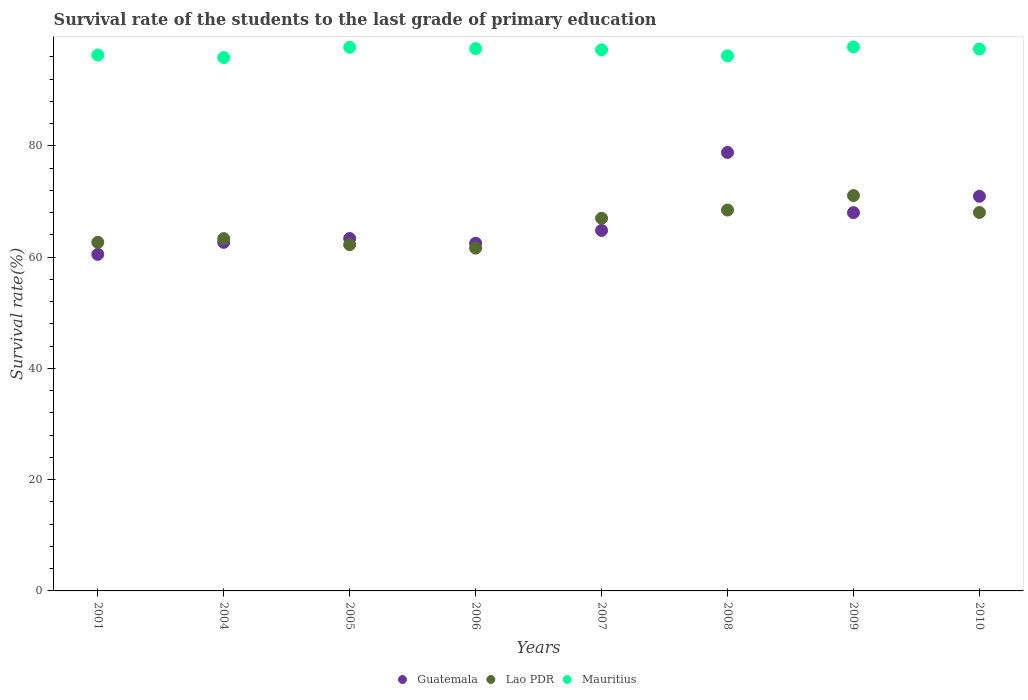How many different coloured dotlines are there?
Keep it short and to the point. 3. What is the survival rate of the students in Mauritius in 2009?
Offer a very short reply. 97.77. Across all years, what is the maximum survival rate of the students in Lao PDR?
Provide a short and direct response. 71.05. Across all years, what is the minimum survival rate of the students in Lao PDR?
Your response must be concise. 61.61. In which year was the survival rate of the students in Mauritius maximum?
Give a very brief answer. 2009. What is the total survival rate of the students in Guatemala in the graph?
Provide a short and direct response. 531.49. What is the difference between the survival rate of the students in Mauritius in 2004 and that in 2006?
Your answer should be very brief. -1.6. What is the difference between the survival rate of the students in Guatemala in 2004 and the survival rate of the students in Lao PDR in 2005?
Give a very brief answer. 0.41. What is the average survival rate of the students in Guatemala per year?
Provide a succinct answer. 66.44. In the year 2009, what is the difference between the survival rate of the students in Guatemala and survival rate of the students in Lao PDR?
Provide a succinct answer. -3.07. What is the ratio of the survival rate of the students in Lao PDR in 2001 to that in 2004?
Keep it short and to the point. 0.99. Is the survival rate of the students in Guatemala in 2001 less than that in 2008?
Keep it short and to the point. Yes. Is the difference between the survival rate of the students in Guatemala in 2001 and 2008 greater than the difference between the survival rate of the students in Lao PDR in 2001 and 2008?
Keep it short and to the point. No. What is the difference between the highest and the second highest survival rate of the students in Mauritius?
Your response must be concise. 0.06. What is the difference between the highest and the lowest survival rate of the students in Lao PDR?
Provide a short and direct response. 9.44. Is the sum of the survival rate of the students in Guatemala in 2006 and 2010 greater than the maximum survival rate of the students in Mauritius across all years?
Your answer should be very brief. Yes. Does the survival rate of the students in Mauritius monotonically increase over the years?
Offer a terse response. No. Is the survival rate of the students in Lao PDR strictly greater than the survival rate of the students in Mauritius over the years?
Your answer should be compact. No. Is the survival rate of the students in Guatemala strictly less than the survival rate of the students in Mauritius over the years?
Provide a short and direct response. Yes. How many dotlines are there?
Your answer should be very brief. 3. What is the difference between two consecutive major ticks on the Y-axis?
Give a very brief answer. 20. Are the values on the major ticks of Y-axis written in scientific E-notation?
Give a very brief answer. No. Does the graph contain any zero values?
Keep it short and to the point. No. How are the legend labels stacked?
Keep it short and to the point. Horizontal. What is the title of the graph?
Offer a terse response. Survival rate of the students to the last grade of primary education. What is the label or title of the X-axis?
Your response must be concise. Years. What is the label or title of the Y-axis?
Your response must be concise. Survival rate(%). What is the Survival rate(%) of Guatemala in 2001?
Provide a succinct answer. 60.49. What is the Survival rate(%) in Lao PDR in 2001?
Your answer should be compact. 62.66. What is the Survival rate(%) of Mauritius in 2001?
Keep it short and to the point. 96.32. What is the Survival rate(%) of Guatemala in 2004?
Provide a succinct answer. 62.65. What is the Survival rate(%) of Lao PDR in 2004?
Your response must be concise. 63.33. What is the Survival rate(%) of Mauritius in 2004?
Offer a very short reply. 95.87. What is the Survival rate(%) in Guatemala in 2005?
Give a very brief answer. 63.34. What is the Survival rate(%) in Lao PDR in 2005?
Offer a terse response. 62.23. What is the Survival rate(%) of Mauritius in 2005?
Ensure brevity in your answer.  97.71. What is the Survival rate(%) of Guatemala in 2006?
Provide a short and direct response. 62.49. What is the Survival rate(%) in Lao PDR in 2006?
Offer a very short reply. 61.61. What is the Survival rate(%) of Mauritius in 2006?
Keep it short and to the point. 97.47. What is the Survival rate(%) of Guatemala in 2007?
Provide a short and direct response. 64.79. What is the Survival rate(%) of Lao PDR in 2007?
Provide a short and direct response. 66.98. What is the Survival rate(%) of Mauritius in 2007?
Keep it short and to the point. 97.25. What is the Survival rate(%) of Guatemala in 2008?
Provide a short and direct response. 78.81. What is the Survival rate(%) of Lao PDR in 2008?
Provide a succinct answer. 68.45. What is the Survival rate(%) in Mauritius in 2008?
Provide a succinct answer. 96.17. What is the Survival rate(%) of Guatemala in 2009?
Give a very brief answer. 67.98. What is the Survival rate(%) of Lao PDR in 2009?
Your answer should be compact. 71.05. What is the Survival rate(%) in Mauritius in 2009?
Your response must be concise. 97.77. What is the Survival rate(%) of Guatemala in 2010?
Make the answer very short. 70.93. What is the Survival rate(%) of Lao PDR in 2010?
Give a very brief answer. 68.02. What is the Survival rate(%) in Mauritius in 2010?
Provide a succinct answer. 97.4. Across all years, what is the maximum Survival rate(%) of Guatemala?
Provide a succinct answer. 78.81. Across all years, what is the maximum Survival rate(%) in Lao PDR?
Offer a terse response. 71.05. Across all years, what is the maximum Survival rate(%) in Mauritius?
Ensure brevity in your answer.  97.77. Across all years, what is the minimum Survival rate(%) in Guatemala?
Your answer should be very brief. 60.49. Across all years, what is the minimum Survival rate(%) in Lao PDR?
Offer a terse response. 61.61. Across all years, what is the minimum Survival rate(%) of Mauritius?
Your answer should be very brief. 95.87. What is the total Survival rate(%) of Guatemala in the graph?
Offer a terse response. 531.49. What is the total Survival rate(%) of Lao PDR in the graph?
Give a very brief answer. 524.33. What is the total Survival rate(%) of Mauritius in the graph?
Offer a terse response. 775.96. What is the difference between the Survival rate(%) in Guatemala in 2001 and that in 2004?
Offer a terse response. -2.16. What is the difference between the Survival rate(%) of Lao PDR in 2001 and that in 2004?
Your answer should be compact. -0.67. What is the difference between the Survival rate(%) of Mauritius in 2001 and that in 2004?
Your answer should be compact. 0.45. What is the difference between the Survival rate(%) of Guatemala in 2001 and that in 2005?
Provide a short and direct response. -2.85. What is the difference between the Survival rate(%) of Lao PDR in 2001 and that in 2005?
Your answer should be compact. 0.42. What is the difference between the Survival rate(%) in Mauritius in 2001 and that in 2005?
Offer a terse response. -1.39. What is the difference between the Survival rate(%) of Guatemala in 2001 and that in 2006?
Your response must be concise. -2. What is the difference between the Survival rate(%) of Lao PDR in 2001 and that in 2006?
Your answer should be very brief. 1.04. What is the difference between the Survival rate(%) of Mauritius in 2001 and that in 2006?
Your answer should be very brief. -1.15. What is the difference between the Survival rate(%) of Guatemala in 2001 and that in 2007?
Make the answer very short. -4.3. What is the difference between the Survival rate(%) of Lao PDR in 2001 and that in 2007?
Your answer should be very brief. -4.32. What is the difference between the Survival rate(%) of Mauritius in 2001 and that in 2007?
Your answer should be compact. -0.93. What is the difference between the Survival rate(%) in Guatemala in 2001 and that in 2008?
Your answer should be very brief. -18.32. What is the difference between the Survival rate(%) in Lao PDR in 2001 and that in 2008?
Ensure brevity in your answer.  -5.8. What is the difference between the Survival rate(%) in Mauritius in 2001 and that in 2008?
Keep it short and to the point. 0.15. What is the difference between the Survival rate(%) in Guatemala in 2001 and that in 2009?
Your response must be concise. -7.49. What is the difference between the Survival rate(%) of Lao PDR in 2001 and that in 2009?
Ensure brevity in your answer.  -8.4. What is the difference between the Survival rate(%) of Mauritius in 2001 and that in 2009?
Ensure brevity in your answer.  -1.45. What is the difference between the Survival rate(%) in Guatemala in 2001 and that in 2010?
Ensure brevity in your answer.  -10.44. What is the difference between the Survival rate(%) of Lao PDR in 2001 and that in 2010?
Your answer should be very brief. -5.36. What is the difference between the Survival rate(%) in Mauritius in 2001 and that in 2010?
Offer a terse response. -1.08. What is the difference between the Survival rate(%) in Guatemala in 2004 and that in 2005?
Keep it short and to the point. -0.69. What is the difference between the Survival rate(%) in Lao PDR in 2004 and that in 2005?
Ensure brevity in your answer.  1.09. What is the difference between the Survival rate(%) of Mauritius in 2004 and that in 2005?
Your response must be concise. -1.84. What is the difference between the Survival rate(%) of Guatemala in 2004 and that in 2006?
Provide a short and direct response. 0.15. What is the difference between the Survival rate(%) of Lao PDR in 2004 and that in 2006?
Your answer should be compact. 1.71. What is the difference between the Survival rate(%) of Mauritius in 2004 and that in 2006?
Offer a terse response. -1.6. What is the difference between the Survival rate(%) in Guatemala in 2004 and that in 2007?
Your response must be concise. -2.14. What is the difference between the Survival rate(%) in Lao PDR in 2004 and that in 2007?
Your answer should be compact. -3.65. What is the difference between the Survival rate(%) in Mauritius in 2004 and that in 2007?
Offer a very short reply. -1.38. What is the difference between the Survival rate(%) in Guatemala in 2004 and that in 2008?
Your answer should be compact. -16.16. What is the difference between the Survival rate(%) of Lao PDR in 2004 and that in 2008?
Your answer should be very brief. -5.13. What is the difference between the Survival rate(%) of Mauritius in 2004 and that in 2008?
Your response must be concise. -0.3. What is the difference between the Survival rate(%) of Guatemala in 2004 and that in 2009?
Ensure brevity in your answer.  -5.34. What is the difference between the Survival rate(%) in Lao PDR in 2004 and that in 2009?
Provide a short and direct response. -7.73. What is the difference between the Survival rate(%) of Mauritius in 2004 and that in 2009?
Ensure brevity in your answer.  -1.9. What is the difference between the Survival rate(%) of Guatemala in 2004 and that in 2010?
Your answer should be very brief. -8.28. What is the difference between the Survival rate(%) in Lao PDR in 2004 and that in 2010?
Your answer should be very brief. -4.69. What is the difference between the Survival rate(%) of Mauritius in 2004 and that in 2010?
Keep it short and to the point. -1.53. What is the difference between the Survival rate(%) of Guatemala in 2005 and that in 2006?
Give a very brief answer. 0.85. What is the difference between the Survival rate(%) of Lao PDR in 2005 and that in 2006?
Your answer should be compact. 0.62. What is the difference between the Survival rate(%) of Mauritius in 2005 and that in 2006?
Provide a succinct answer. 0.24. What is the difference between the Survival rate(%) in Guatemala in 2005 and that in 2007?
Your answer should be compact. -1.45. What is the difference between the Survival rate(%) of Lao PDR in 2005 and that in 2007?
Your answer should be very brief. -4.74. What is the difference between the Survival rate(%) in Mauritius in 2005 and that in 2007?
Provide a succinct answer. 0.45. What is the difference between the Survival rate(%) in Guatemala in 2005 and that in 2008?
Provide a short and direct response. -15.47. What is the difference between the Survival rate(%) of Lao PDR in 2005 and that in 2008?
Make the answer very short. -6.22. What is the difference between the Survival rate(%) in Mauritius in 2005 and that in 2008?
Ensure brevity in your answer.  1.54. What is the difference between the Survival rate(%) of Guatemala in 2005 and that in 2009?
Make the answer very short. -4.64. What is the difference between the Survival rate(%) of Lao PDR in 2005 and that in 2009?
Your answer should be very brief. -8.82. What is the difference between the Survival rate(%) in Mauritius in 2005 and that in 2009?
Your answer should be very brief. -0.06. What is the difference between the Survival rate(%) of Guatemala in 2005 and that in 2010?
Your response must be concise. -7.58. What is the difference between the Survival rate(%) in Lao PDR in 2005 and that in 2010?
Give a very brief answer. -5.78. What is the difference between the Survival rate(%) of Mauritius in 2005 and that in 2010?
Ensure brevity in your answer.  0.31. What is the difference between the Survival rate(%) of Guatemala in 2006 and that in 2007?
Ensure brevity in your answer.  -2.3. What is the difference between the Survival rate(%) in Lao PDR in 2006 and that in 2007?
Provide a succinct answer. -5.36. What is the difference between the Survival rate(%) in Mauritius in 2006 and that in 2007?
Your response must be concise. 0.22. What is the difference between the Survival rate(%) in Guatemala in 2006 and that in 2008?
Provide a succinct answer. -16.32. What is the difference between the Survival rate(%) of Lao PDR in 2006 and that in 2008?
Your response must be concise. -6.84. What is the difference between the Survival rate(%) of Mauritius in 2006 and that in 2008?
Give a very brief answer. 1.3. What is the difference between the Survival rate(%) in Guatemala in 2006 and that in 2009?
Your answer should be very brief. -5.49. What is the difference between the Survival rate(%) in Lao PDR in 2006 and that in 2009?
Offer a terse response. -9.44. What is the difference between the Survival rate(%) of Mauritius in 2006 and that in 2009?
Offer a very short reply. -0.3. What is the difference between the Survival rate(%) of Guatemala in 2006 and that in 2010?
Provide a short and direct response. -8.43. What is the difference between the Survival rate(%) in Lao PDR in 2006 and that in 2010?
Keep it short and to the point. -6.4. What is the difference between the Survival rate(%) in Mauritius in 2006 and that in 2010?
Offer a terse response. 0.08. What is the difference between the Survival rate(%) of Guatemala in 2007 and that in 2008?
Keep it short and to the point. -14.02. What is the difference between the Survival rate(%) of Lao PDR in 2007 and that in 2008?
Offer a terse response. -1.48. What is the difference between the Survival rate(%) in Mauritius in 2007 and that in 2008?
Keep it short and to the point. 1.09. What is the difference between the Survival rate(%) in Guatemala in 2007 and that in 2009?
Make the answer very short. -3.19. What is the difference between the Survival rate(%) in Lao PDR in 2007 and that in 2009?
Your response must be concise. -4.08. What is the difference between the Survival rate(%) of Mauritius in 2007 and that in 2009?
Your response must be concise. -0.51. What is the difference between the Survival rate(%) of Guatemala in 2007 and that in 2010?
Ensure brevity in your answer.  -6.14. What is the difference between the Survival rate(%) of Lao PDR in 2007 and that in 2010?
Offer a very short reply. -1.04. What is the difference between the Survival rate(%) in Mauritius in 2007 and that in 2010?
Ensure brevity in your answer.  -0.14. What is the difference between the Survival rate(%) of Guatemala in 2008 and that in 2009?
Offer a terse response. 10.83. What is the difference between the Survival rate(%) in Lao PDR in 2008 and that in 2009?
Ensure brevity in your answer.  -2.6. What is the difference between the Survival rate(%) in Mauritius in 2008 and that in 2009?
Ensure brevity in your answer.  -1.6. What is the difference between the Survival rate(%) of Guatemala in 2008 and that in 2010?
Provide a succinct answer. 7.89. What is the difference between the Survival rate(%) of Lao PDR in 2008 and that in 2010?
Keep it short and to the point. 0.44. What is the difference between the Survival rate(%) in Mauritius in 2008 and that in 2010?
Offer a very short reply. -1.23. What is the difference between the Survival rate(%) of Guatemala in 2009 and that in 2010?
Your response must be concise. -2.94. What is the difference between the Survival rate(%) in Lao PDR in 2009 and that in 2010?
Give a very brief answer. 3.04. What is the difference between the Survival rate(%) in Mauritius in 2009 and that in 2010?
Your response must be concise. 0.37. What is the difference between the Survival rate(%) in Guatemala in 2001 and the Survival rate(%) in Lao PDR in 2004?
Your answer should be very brief. -2.84. What is the difference between the Survival rate(%) in Guatemala in 2001 and the Survival rate(%) in Mauritius in 2004?
Offer a terse response. -35.38. What is the difference between the Survival rate(%) in Lao PDR in 2001 and the Survival rate(%) in Mauritius in 2004?
Give a very brief answer. -33.21. What is the difference between the Survival rate(%) in Guatemala in 2001 and the Survival rate(%) in Lao PDR in 2005?
Offer a very short reply. -1.74. What is the difference between the Survival rate(%) of Guatemala in 2001 and the Survival rate(%) of Mauritius in 2005?
Provide a succinct answer. -37.22. What is the difference between the Survival rate(%) in Lao PDR in 2001 and the Survival rate(%) in Mauritius in 2005?
Ensure brevity in your answer.  -35.05. What is the difference between the Survival rate(%) in Guatemala in 2001 and the Survival rate(%) in Lao PDR in 2006?
Provide a short and direct response. -1.12. What is the difference between the Survival rate(%) in Guatemala in 2001 and the Survival rate(%) in Mauritius in 2006?
Give a very brief answer. -36.98. What is the difference between the Survival rate(%) in Lao PDR in 2001 and the Survival rate(%) in Mauritius in 2006?
Your answer should be compact. -34.82. What is the difference between the Survival rate(%) in Guatemala in 2001 and the Survival rate(%) in Lao PDR in 2007?
Ensure brevity in your answer.  -6.49. What is the difference between the Survival rate(%) in Guatemala in 2001 and the Survival rate(%) in Mauritius in 2007?
Offer a very short reply. -36.76. What is the difference between the Survival rate(%) of Lao PDR in 2001 and the Survival rate(%) of Mauritius in 2007?
Provide a short and direct response. -34.6. What is the difference between the Survival rate(%) in Guatemala in 2001 and the Survival rate(%) in Lao PDR in 2008?
Offer a very short reply. -7.96. What is the difference between the Survival rate(%) in Guatemala in 2001 and the Survival rate(%) in Mauritius in 2008?
Give a very brief answer. -35.68. What is the difference between the Survival rate(%) in Lao PDR in 2001 and the Survival rate(%) in Mauritius in 2008?
Your answer should be compact. -33.51. What is the difference between the Survival rate(%) in Guatemala in 2001 and the Survival rate(%) in Lao PDR in 2009?
Provide a succinct answer. -10.56. What is the difference between the Survival rate(%) in Guatemala in 2001 and the Survival rate(%) in Mauritius in 2009?
Your answer should be very brief. -37.28. What is the difference between the Survival rate(%) of Lao PDR in 2001 and the Survival rate(%) of Mauritius in 2009?
Ensure brevity in your answer.  -35.11. What is the difference between the Survival rate(%) of Guatemala in 2001 and the Survival rate(%) of Lao PDR in 2010?
Make the answer very short. -7.53. What is the difference between the Survival rate(%) of Guatemala in 2001 and the Survival rate(%) of Mauritius in 2010?
Provide a short and direct response. -36.91. What is the difference between the Survival rate(%) of Lao PDR in 2001 and the Survival rate(%) of Mauritius in 2010?
Your answer should be very brief. -34.74. What is the difference between the Survival rate(%) in Guatemala in 2004 and the Survival rate(%) in Lao PDR in 2005?
Ensure brevity in your answer.  0.41. What is the difference between the Survival rate(%) in Guatemala in 2004 and the Survival rate(%) in Mauritius in 2005?
Provide a short and direct response. -35.06. What is the difference between the Survival rate(%) in Lao PDR in 2004 and the Survival rate(%) in Mauritius in 2005?
Offer a very short reply. -34.38. What is the difference between the Survival rate(%) in Guatemala in 2004 and the Survival rate(%) in Lao PDR in 2006?
Provide a short and direct response. 1.04. What is the difference between the Survival rate(%) of Guatemala in 2004 and the Survival rate(%) of Mauritius in 2006?
Make the answer very short. -34.82. What is the difference between the Survival rate(%) of Lao PDR in 2004 and the Survival rate(%) of Mauritius in 2006?
Offer a very short reply. -34.15. What is the difference between the Survival rate(%) of Guatemala in 2004 and the Survival rate(%) of Lao PDR in 2007?
Provide a succinct answer. -4.33. What is the difference between the Survival rate(%) of Guatemala in 2004 and the Survival rate(%) of Mauritius in 2007?
Provide a succinct answer. -34.61. What is the difference between the Survival rate(%) in Lao PDR in 2004 and the Survival rate(%) in Mauritius in 2007?
Your response must be concise. -33.93. What is the difference between the Survival rate(%) of Guatemala in 2004 and the Survival rate(%) of Lao PDR in 2008?
Ensure brevity in your answer.  -5.8. What is the difference between the Survival rate(%) in Guatemala in 2004 and the Survival rate(%) in Mauritius in 2008?
Provide a short and direct response. -33.52. What is the difference between the Survival rate(%) in Lao PDR in 2004 and the Survival rate(%) in Mauritius in 2008?
Ensure brevity in your answer.  -32.84. What is the difference between the Survival rate(%) in Guatemala in 2004 and the Survival rate(%) in Lao PDR in 2009?
Your answer should be very brief. -8.41. What is the difference between the Survival rate(%) of Guatemala in 2004 and the Survival rate(%) of Mauritius in 2009?
Offer a terse response. -35.12. What is the difference between the Survival rate(%) in Lao PDR in 2004 and the Survival rate(%) in Mauritius in 2009?
Your response must be concise. -34.44. What is the difference between the Survival rate(%) of Guatemala in 2004 and the Survival rate(%) of Lao PDR in 2010?
Provide a short and direct response. -5.37. What is the difference between the Survival rate(%) of Guatemala in 2004 and the Survival rate(%) of Mauritius in 2010?
Give a very brief answer. -34.75. What is the difference between the Survival rate(%) of Lao PDR in 2004 and the Survival rate(%) of Mauritius in 2010?
Your answer should be very brief. -34.07. What is the difference between the Survival rate(%) in Guatemala in 2005 and the Survival rate(%) in Lao PDR in 2006?
Your answer should be compact. 1.73. What is the difference between the Survival rate(%) in Guatemala in 2005 and the Survival rate(%) in Mauritius in 2006?
Make the answer very short. -34.13. What is the difference between the Survival rate(%) in Lao PDR in 2005 and the Survival rate(%) in Mauritius in 2006?
Keep it short and to the point. -35.24. What is the difference between the Survival rate(%) in Guatemala in 2005 and the Survival rate(%) in Lao PDR in 2007?
Make the answer very short. -3.63. What is the difference between the Survival rate(%) of Guatemala in 2005 and the Survival rate(%) of Mauritius in 2007?
Make the answer very short. -33.91. What is the difference between the Survival rate(%) in Lao PDR in 2005 and the Survival rate(%) in Mauritius in 2007?
Your answer should be very brief. -35.02. What is the difference between the Survival rate(%) in Guatemala in 2005 and the Survival rate(%) in Lao PDR in 2008?
Ensure brevity in your answer.  -5.11. What is the difference between the Survival rate(%) in Guatemala in 2005 and the Survival rate(%) in Mauritius in 2008?
Give a very brief answer. -32.83. What is the difference between the Survival rate(%) in Lao PDR in 2005 and the Survival rate(%) in Mauritius in 2008?
Provide a succinct answer. -33.93. What is the difference between the Survival rate(%) of Guatemala in 2005 and the Survival rate(%) of Lao PDR in 2009?
Offer a terse response. -7.71. What is the difference between the Survival rate(%) of Guatemala in 2005 and the Survival rate(%) of Mauritius in 2009?
Your answer should be very brief. -34.43. What is the difference between the Survival rate(%) in Lao PDR in 2005 and the Survival rate(%) in Mauritius in 2009?
Your answer should be very brief. -35.53. What is the difference between the Survival rate(%) of Guatemala in 2005 and the Survival rate(%) of Lao PDR in 2010?
Provide a short and direct response. -4.67. What is the difference between the Survival rate(%) of Guatemala in 2005 and the Survival rate(%) of Mauritius in 2010?
Ensure brevity in your answer.  -34.05. What is the difference between the Survival rate(%) in Lao PDR in 2005 and the Survival rate(%) in Mauritius in 2010?
Offer a terse response. -35.16. What is the difference between the Survival rate(%) of Guatemala in 2006 and the Survival rate(%) of Lao PDR in 2007?
Provide a succinct answer. -4.48. What is the difference between the Survival rate(%) in Guatemala in 2006 and the Survival rate(%) in Mauritius in 2007?
Your answer should be compact. -34.76. What is the difference between the Survival rate(%) in Lao PDR in 2006 and the Survival rate(%) in Mauritius in 2007?
Make the answer very short. -35.64. What is the difference between the Survival rate(%) of Guatemala in 2006 and the Survival rate(%) of Lao PDR in 2008?
Provide a succinct answer. -5.96. What is the difference between the Survival rate(%) of Guatemala in 2006 and the Survival rate(%) of Mauritius in 2008?
Ensure brevity in your answer.  -33.67. What is the difference between the Survival rate(%) in Lao PDR in 2006 and the Survival rate(%) in Mauritius in 2008?
Make the answer very short. -34.56. What is the difference between the Survival rate(%) of Guatemala in 2006 and the Survival rate(%) of Lao PDR in 2009?
Your answer should be very brief. -8.56. What is the difference between the Survival rate(%) of Guatemala in 2006 and the Survival rate(%) of Mauritius in 2009?
Offer a terse response. -35.27. What is the difference between the Survival rate(%) in Lao PDR in 2006 and the Survival rate(%) in Mauritius in 2009?
Make the answer very short. -36.15. What is the difference between the Survival rate(%) of Guatemala in 2006 and the Survival rate(%) of Lao PDR in 2010?
Keep it short and to the point. -5.52. What is the difference between the Survival rate(%) of Guatemala in 2006 and the Survival rate(%) of Mauritius in 2010?
Provide a short and direct response. -34.9. What is the difference between the Survival rate(%) in Lao PDR in 2006 and the Survival rate(%) in Mauritius in 2010?
Offer a terse response. -35.78. What is the difference between the Survival rate(%) in Guatemala in 2007 and the Survival rate(%) in Lao PDR in 2008?
Offer a very short reply. -3.66. What is the difference between the Survival rate(%) of Guatemala in 2007 and the Survival rate(%) of Mauritius in 2008?
Offer a terse response. -31.38. What is the difference between the Survival rate(%) in Lao PDR in 2007 and the Survival rate(%) in Mauritius in 2008?
Offer a terse response. -29.19. What is the difference between the Survival rate(%) of Guatemala in 2007 and the Survival rate(%) of Lao PDR in 2009?
Keep it short and to the point. -6.26. What is the difference between the Survival rate(%) of Guatemala in 2007 and the Survival rate(%) of Mauritius in 2009?
Provide a short and direct response. -32.98. What is the difference between the Survival rate(%) of Lao PDR in 2007 and the Survival rate(%) of Mauritius in 2009?
Provide a succinct answer. -30.79. What is the difference between the Survival rate(%) of Guatemala in 2007 and the Survival rate(%) of Lao PDR in 2010?
Make the answer very short. -3.23. What is the difference between the Survival rate(%) of Guatemala in 2007 and the Survival rate(%) of Mauritius in 2010?
Your answer should be compact. -32.61. What is the difference between the Survival rate(%) of Lao PDR in 2007 and the Survival rate(%) of Mauritius in 2010?
Ensure brevity in your answer.  -30.42. What is the difference between the Survival rate(%) of Guatemala in 2008 and the Survival rate(%) of Lao PDR in 2009?
Make the answer very short. 7.76. What is the difference between the Survival rate(%) of Guatemala in 2008 and the Survival rate(%) of Mauritius in 2009?
Your answer should be compact. -18.95. What is the difference between the Survival rate(%) of Lao PDR in 2008 and the Survival rate(%) of Mauritius in 2009?
Ensure brevity in your answer.  -29.32. What is the difference between the Survival rate(%) in Guatemala in 2008 and the Survival rate(%) in Lao PDR in 2010?
Ensure brevity in your answer.  10.8. What is the difference between the Survival rate(%) in Guatemala in 2008 and the Survival rate(%) in Mauritius in 2010?
Ensure brevity in your answer.  -18.58. What is the difference between the Survival rate(%) of Lao PDR in 2008 and the Survival rate(%) of Mauritius in 2010?
Your answer should be compact. -28.94. What is the difference between the Survival rate(%) in Guatemala in 2009 and the Survival rate(%) in Lao PDR in 2010?
Provide a succinct answer. -0.03. What is the difference between the Survival rate(%) in Guatemala in 2009 and the Survival rate(%) in Mauritius in 2010?
Give a very brief answer. -29.41. What is the difference between the Survival rate(%) of Lao PDR in 2009 and the Survival rate(%) of Mauritius in 2010?
Ensure brevity in your answer.  -26.34. What is the average Survival rate(%) in Guatemala per year?
Your response must be concise. 66.44. What is the average Survival rate(%) of Lao PDR per year?
Give a very brief answer. 65.54. What is the average Survival rate(%) of Mauritius per year?
Keep it short and to the point. 96.99. In the year 2001, what is the difference between the Survival rate(%) of Guatemala and Survival rate(%) of Lao PDR?
Give a very brief answer. -2.17. In the year 2001, what is the difference between the Survival rate(%) in Guatemala and Survival rate(%) in Mauritius?
Give a very brief answer. -35.83. In the year 2001, what is the difference between the Survival rate(%) of Lao PDR and Survival rate(%) of Mauritius?
Make the answer very short. -33.66. In the year 2004, what is the difference between the Survival rate(%) of Guatemala and Survival rate(%) of Lao PDR?
Make the answer very short. -0.68. In the year 2004, what is the difference between the Survival rate(%) of Guatemala and Survival rate(%) of Mauritius?
Keep it short and to the point. -33.22. In the year 2004, what is the difference between the Survival rate(%) of Lao PDR and Survival rate(%) of Mauritius?
Provide a succinct answer. -32.54. In the year 2005, what is the difference between the Survival rate(%) of Guatemala and Survival rate(%) of Lao PDR?
Offer a very short reply. 1.11. In the year 2005, what is the difference between the Survival rate(%) of Guatemala and Survival rate(%) of Mauritius?
Ensure brevity in your answer.  -34.37. In the year 2005, what is the difference between the Survival rate(%) in Lao PDR and Survival rate(%) in Mauritius?
Your answer should be compact. -35.48. In the year 2006, what is the difference between the Survival rate(%) in Guatemala and Survival rate(%) in Lao PDR?
Your answer should be compact. 0.88. In the year 2006, what is the difference between the Survival rate(%) of Guatemala and Survival rate(%) of Mauritius?
Give a very brief answer. -34.98. In the year 2006, what is the difference between the Survival rate(%) of Lao PDR and Survival rate(%) of Mauritius?
Give a very brief answer. -35.86. In the year 2007, what is the difference between the Survival rate(%) in Guatemala and Survival rate(%) in Lao PDR?
Your response must be concise. -2.18. In the year 2007, what is the difference between the Survival rate(%) in Guatemala and Survival rate(%) in Mauritius?
Provide a short and direct response. -32.46. In the year 2007, what is the difference between the Survival rate(%) in Lao PDR and Survival rate(%) in Mauritius?
Offer a terse response. -30.28. In the year 2008, what is the difference between the Survival rate(%) of Guatemala and Survival rate(%) of Lao PDR?
Your answer should be compact. 10.36. In the year 2008, what is the difference between the Survival rate(%) of Guatemala and Survival rate(%) of Mauritius?
Give a very brief answer. -17.36. In the year 2008, what is the difference between the Survival rate(%) in Lao PDR and Survival rate(%) in Mauritius?
Provide a short and direct response. -27.72. In the year 2009, what is the difference between the Survival rate(%) of Guatemala and Survival rate(%) of Lao PDR?
Make the answer very short. -3.07. In the year 2009, what is the difference between the Survival rate(%) in Guatemala and Survival rate(%) in Mauritius?
Provide a short and direct response. -29.78. In the year 2009, what is the difference between the Survival rate(%) in Lao PDR and Survival rate(%) in Mauritius?
Offer a terse response. -26.71. In the year 2010, what is the difference between the Survival rate(%) in Guatemala and Survival rate(%) in Lao PDR?
Give a very brief answer. 2.91. In the year 2010, what is the difference between the Survival rate(%) of Guatemala and Survival rate(%) of Mauritius?
Make the answer very short. -26.47. In the year 2010, what is the difference between the Survival rate(%) in Lao PDR and Survival rate(%) in Mauritius?
Provide a succinct answer. -29.38. What is the ratio of the Survival rate(%) of Guatemala in 2001 to that in 2004?
Provide a succinct answer. 0.97. What is the ratio of the Survival rate(%) in Lao PDR in 2001 to that in 2004?
Give a very brief answer. 0.99. What is the ratio of the Survival rate(%) in Guatemala in 2001 to that in 2005?
Keep it short and to the point. 0.95. What is the ratio of the Survival rate(%) in Lao PDR in 2001 to that in 2005?
Your answer should be very brief. 1.01. What is the ratio of the Survival rate(%) of Mauritius in 2001 to that in 2005?
Give a very brief answer. 0.99. What is the ratio of the Survival rate(%) in Guatemala in 2001 to that in 2006?
Your response must be concise. 0.97. What is the ratio of the Survival rate(%) of Lao PDR in 2001 to that in 2006?
Give a very brief answer. 1.02. What is the ratio of the Survival rate(%) in Mauritius in 2001 to that in 2006?
Your answer should be compact. 0.99. What is the ratio of the Survival rate(%) in Guatemala in 2001 to that in 2007?
Provide a short and direct response. 0.93. What is the ratio of the Survival rate(%) in Lao PDR in 2001 to that in 2007?
Give a very brief answer. 0.94. What is the ratio of the Survival rate(%) of Guatemala in 2001 to that in 2008?
Ensure brevity in your answer.  0.77. What is the ratio of the Survival rate(%) in Lao PDR in 2001 to that in 2008?
Give a very brief answer. 0.92. What is the ratio of the Survival rate(%) of Mauritius in 2001 to that in 2008?
Provide a succinct answer. 1. What is the ratio of the Survival rate(%) of Guatemala in 2001 to that in 2009?
Offer a terse response. 0.89. What is the ratio of the Survival rate(%) in Lao PDR in 2001 to that in 2009?
Ensure brevity in your answer.  0.88. What is the ratio of the Survival rate(%) in Mauritius in 2001 to that in 2009?
Provide a short and direct response. 0.99. What is the ratio of the Survival rate(%) in Guatemala in 2001 to that in 2010?
Keep it short and to the point. 0.85. What is the ratio of the Survival rate(%) of Lao PDR in 2001 to that in 2010?
Ensure brevity in your answer.  0.92. What is the ratio of the Survival rate(%) in Guatemala in 2004 to that in 2005?
Provide a short and direct response. 0.99. What is the ratio of the Survival rate(%) of Lao PDR in 2004 to that in 2005?
Give a very brief answer. 1.02. What is the ratio of the Survival rate(%) in Mauritius in 2004 to that in 2005?
Your answer should be compact. 0.98. What is the ratio of the Survival rate(%) in Lao PDR in 2004 to that in 2006?
Keep it short and to the point. 1.03. What is the ratio of the Survival rate(%) in Mauritius in 2004 to that in 2006?
Your response must be concise. 0.98. What is the ratio of the Survival rate(%) in Guatemala in 2004 to that in 2007?
Keep it short and to the point. 0.97. What is the ratio of the Survival rate(%) of Lao PDR in 2004 to that in 2007?
Ensure brevity in your answer.  0.95. What is the ratio of the Survival rate(%) in Mauritius in 2004 to that in 2007?
Your answer should be very brief. 0.99. What is the ratio of the Survival rate(%) of Guatemala in 2004 to that in 2008?
Your response must be concise. 0.79. What is the ratio of the Survival rate(%) of Lao PDR in 2004 to that in 2008?
Provide a short and direct response. 0.93. What is the ratio of the Survival rate(%) of Guatemala in 2004 to that in 2009?
Provide a succinct answer. 0.92. What is the ratio of the Survival rate(%) in Lao PDR in 2004 to that in 2009?
Provide a short and direct response. 0.89. What is the ratio of the Survival rate(%) of Mauritius in 2004 to that in 2009?
Offer a terse response. 0.98. What is the ratio of the Survival rate(%) of Guatemala in 2004 to that in 2010?
Your response must be concise. 0.88. What is the ratio of the Survival rate(%) in Mauritius in 2004 to that in 2010?
Make the answer very short. 0.98. What is the ratio of the Survival rate(%) of Guatemala in 2005 to that in 2006?
Offer a terse response. 1.01. What is the ratio of the Survival rate(%) in Lao PDR in 2005 to that in 2006?
Keep it short and to the point. 1.01. What is the ratio of the Survival rate(%) of Guatemala in 2005 to that in 2007?
Ensure brevity in your answer.  0.98. What is the ratio of the Survival rate(%) of Lao PDR in 2005 to that in 2007?
Ensure brevity in your answer.  0.93. What is the ratio of the Survival rate(%) in Mauritius in 2005 to that in 2007?
Keep it short and to the point. 1. What is the ratio of the Survival rate(%) of Guatemala in 2005 to that in 2008?
Ensure brevity in your answer.  0.8. What is the ratio of the Survival rate(%) of Lao PDR in 2005 to that in 2008?
Your answer should be very brief. 0.91. What is the ratio of the Survival rate(%) of Mauritius in 2005 to that in 2008?
Your answer should be very brief. 1.02. What is the ratio of the Survival rate(%) in Guatemala in 2005 to that in 2009?
Ensure brevity in your answer.  0.93. What is the ratio of the Survival rate(%) of Lao PDR in 2005 to that in 2009?
Your answer should be very brief. 0.88. What is the ratio of the Survival rate(%) of Mauritius in 2005 to that in 2009?
Provide a succinct answer. 1. What is the ratio of the Survival rate(%) of Guatemala in 2005 to that in 2010?
Provide a short and direct response. 0.89. What is the ratio of the Survival rate(%) of Lao PDR in 2005 to that in 2010?
Provide a short and direct response. 0.92. What is the ratio of the Survival rate(%) in Guatemala in 2006 to that in 2007?
Keep it short and to the point. 0.96. What is the ratio of the Survival rate(%) in Lao PDR in 2006 to that in 2007?
Give a very brief answer. 0.92. What is the ratio of the Survival rate(%) in Mauritius in 2006 to that in 2007?
Provide a succinct answer. 1. What is the ratio of the Survival rate(%) in Guatemala in 2006 to that in 2008?
Provide a succinct answer. 0.79. What is the ratio of the Survival rate(%) in Lao PDR in 2006 to that in 2008?
Offer a very short reply. 0.9. What is the ratio of the Survival rate(%) in Mauritius in 2006 to that in 2008?
Offer a terse response. 1.01. What is the ratio of the Survival rate(%) of Guatemala in 2006 to that in 2009?
Your answer should be very brief. 0.92. What is the ratio of the Survival rate(%) of Lao PDR in 2006 to that in 2009?
Ensure brevity in your answer.  0.87. What is the ratio of the Survival rate(%) of Guatemala in 2006 to that in 2010?
Your response must be concise. 0.88. What is the ratio of the Survival rate(%) in Lao PDR in 2006 to that in 2010?
Keep it short and to the point. 0.91. What is the ratio of the Survival rate(%) of Guatemala in 2007 to that in 2008?
Keep it short and to the point. 0.82. What is the ratio of the Survival rate(%) of Lao PDR in 2007 to that in 2008?
Keep it short and to the point. 0.98. What is the ratio of the Survival rate(%) in Mauritius in 2007 to that in 2008?
Your response must be concise. 1.01. What is the ratio of the Survival rate(%) in Guatemala in 2007 to that in 2009?
Your response must be concise. 0.95. What is the ratio of the Survival rate(%) in Lao PDR in 2007 to that in 2009?
Your answer should be compact. 0.94. What is the ratio of the Survival rate(%) in Guatemala in 2007 to that in 2010?
Ensure brevity in your answer.  0.91. What is the ratio of the Survival rate(%) of Lao PDR in 2007 to that in 2010?
Offer a terse response. 0.98. What is the ratio of the Survival rate(%) in Guatemala in 2008 to that in 2009?
Make the answer very short. 1.16. What is the ratio of the Survival rate(%) in Lao PDR in 2008 to that in 2009?
Ensure brevity in your answer.  0.96. What is the ratio of the Survival rate(%) of Mauritius in 2008 to that in 2009?
Your answer should be compact. 0.98. What is the ratio of the Survival rate(%) of Guatemala in 2008 to that in 2010?
Provide a succinct answer. 1.11. What is the ratio of the Survival rate(%) in Lao PDR in 2008 to that in 2010?
Your answer should be very brief. 1.01. What is the ratio of the Survival rate(%) in Mauritius in 2008 to that in 2010?
Give a very brief answer. 0.99. What is the ratio of the Survival rate(%) in Guatemala in 2009 to that in 2010?
Give a very brief answer. 0.96. What is the ratio of the Survival rate(%) of Lao PDR in 2009 to that in 2010?
Your answer should be compact. 1.04. What is the ratio of the Survival rate(%) in Mauritius in 2009 to that in 2010?
Your answer should be compact. 1. What is the difference between the highest and the second highest Survival rate(%) in Guatemala?
Ensure brevity in your answer.  7.89. What is the difference between the highest and the second highest Survival rate(%) in Lao PDR?
Give a very brief answer. 2.6. What is the difference between the highest and the second highest Survival rate(%) in Mauritius?
Ensure brevity in your answer.  0.06. What is the difference between the highest and the lowest Survival rate(%) in Guatemala?
Ensure brevity in your answer.  18.32. What is the difference between the highest and the lowest Survival rate(%) of Lao PDR?
Your answer should be compact. 9.44. What is the difference between the highest and the lowest Survival rate(%) of Mauritius?
Make the answer very short. 1.9. 